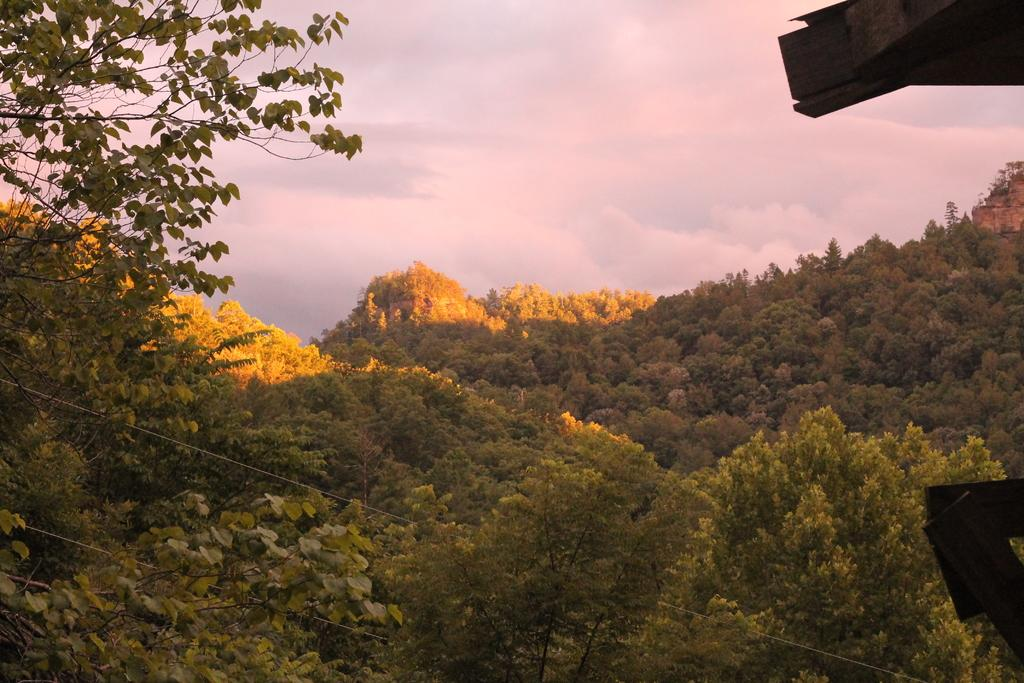What type of vegetation can be seen in the image? There is a group of trees in the image. What else is present in the image besides the trees? Cables and wooden boards are present in the image. What can be seen in the background of the image? The sky is visible in the background of the image, and it appears to be cloudy. What type of current is flowing through the spoon in the image? There is no spoon present in the image, and therefore no current can be observed. Can you see a robin perched on any of the trees in the image? There is no robin present in the image; only trees, cables, and wooden boards are visible. 